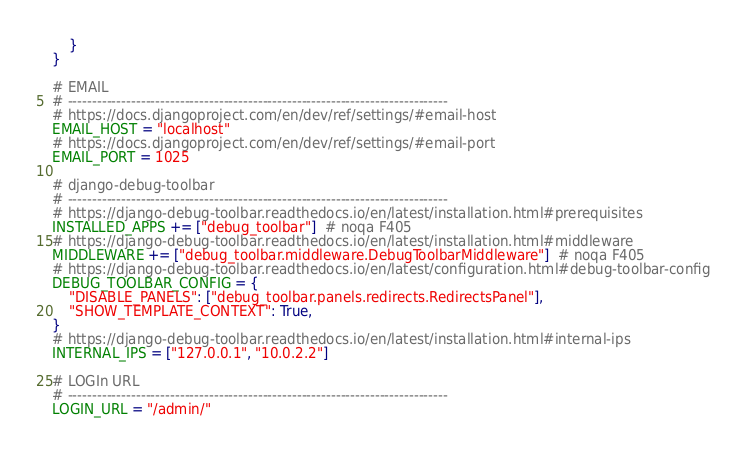Convert code to text. <code><loc_0><loc_0><loc_500><loc_500><_Python_>    }
}

# EMAIL
# ------------------------------------------------------------------------------
# https://docs.djangoproject.com/en/dev/ref/settings/#email-host
EMAIL_HOST = "localhost"
# https://docs.djangoproject.com/en/dev/ref/settings/#email-port
EMAIL_PORT = 1025

# django-debug-toolbar
# ------------------------------------------------------------------------------
# https://django-debug-toolbar.readthedocs.io/en/latest/installation.html#prerequisites
INSTALLED_APPS += ["debug_toolbar"]  # noqa F405
# https://django-debug-toolbar.readthedocs.io/en/latest/installation.html#middleware
MIDDLEWARE += ["debug_toolbar.middleware.DebugToolbarMiddleware"]  # noqa F405
# https://django-debug-toolbar.readthedocs.io/en/latest/configuration.html#debug-toolbar-config
DEBUG_TOOLBAR_CONFIG = {
    "DISABLE_PANELS": ["debug_toolbar.panels.redirects.RedirectsPanel"],
    "SHOW_TEMPLATE_CONTEXT": True,
}
# https://django-debug-toolbar.readthedocs.io/en/latest/installation.html#internal-ips
INTERNAL_IPS = ["127.0.0.1", "10.0.2.2"]

# LOGIn URL
# ------------------------------------------------------------------------------
LOGIN_URL = "/admin/"
</code> 